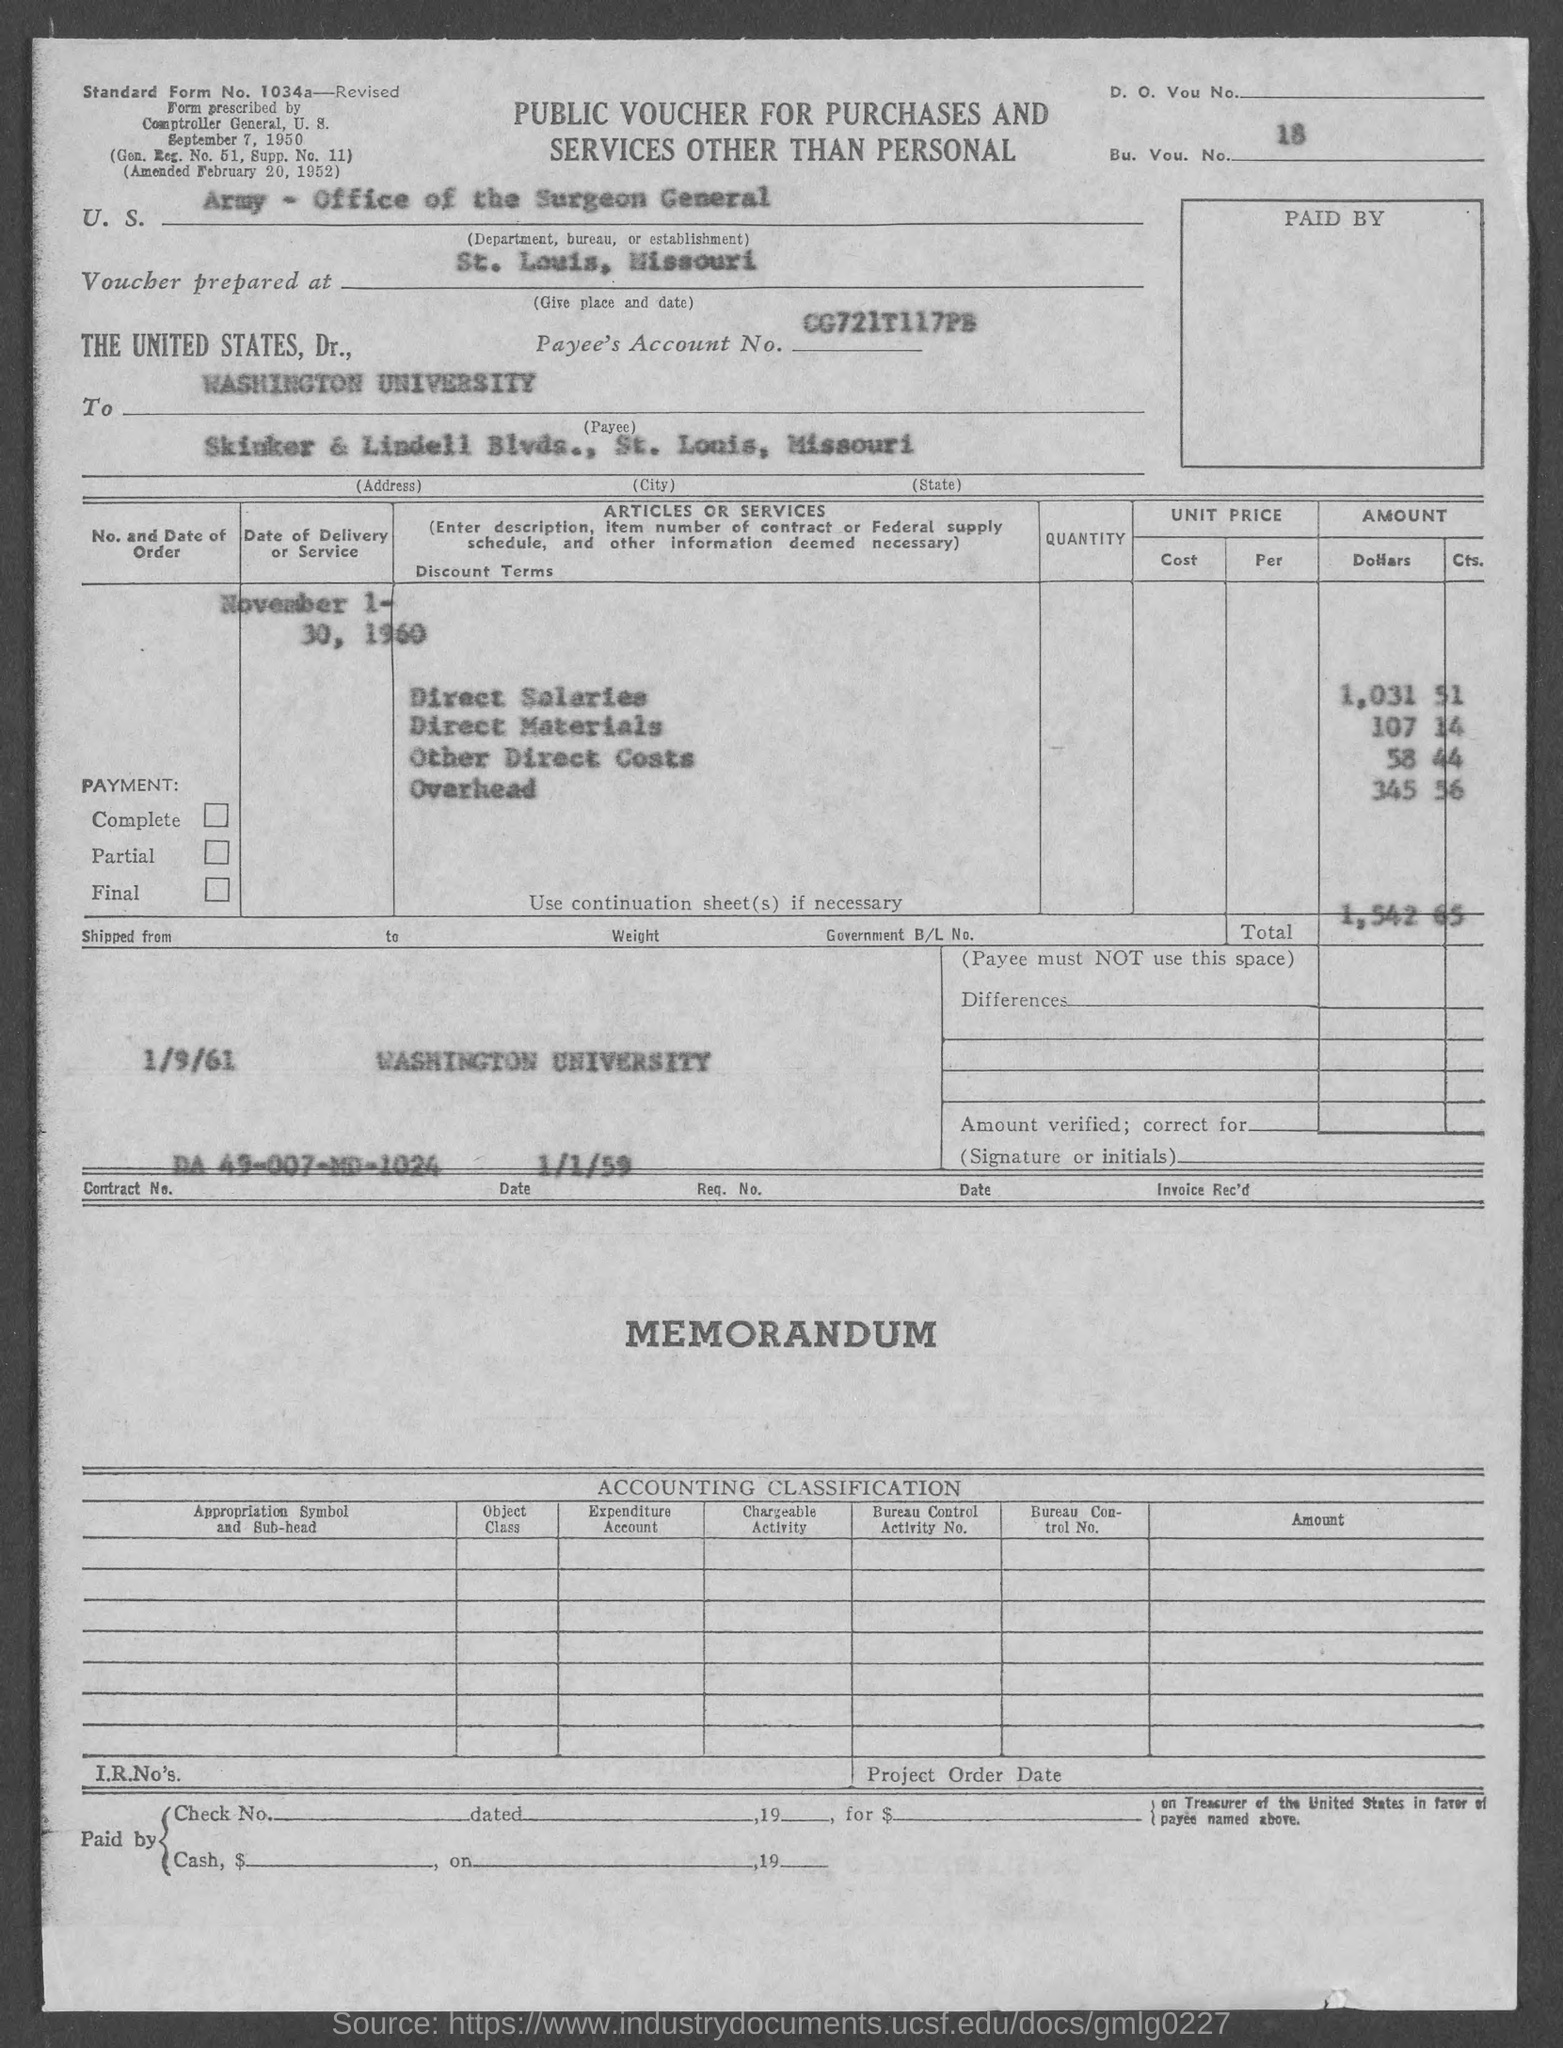What is the bu. vou. no.?
Provide a succinct answer. 18. What is the contract no.?
Give a very brief answer. DA-49-007-MD-1024. What is the total ?
Offer a very short reply. 1542.65. What is the amount of direct salaries ?
Provide a short and direct response. 1,031 51. What is the amount of direct materials ?
Offer a very short reply. 107 14. What is the amount of other direct costs?
Offer a terse response. 58.44. What is the amount of overhead ?
Your answer should be compact. 345 56. In which state is washington university at?
Give a very brief answer. Missouri. What is the gen. reg. no.?
Make the answer very short. 51. What is the supp. no.?
Provide a succinct answer. 11. 